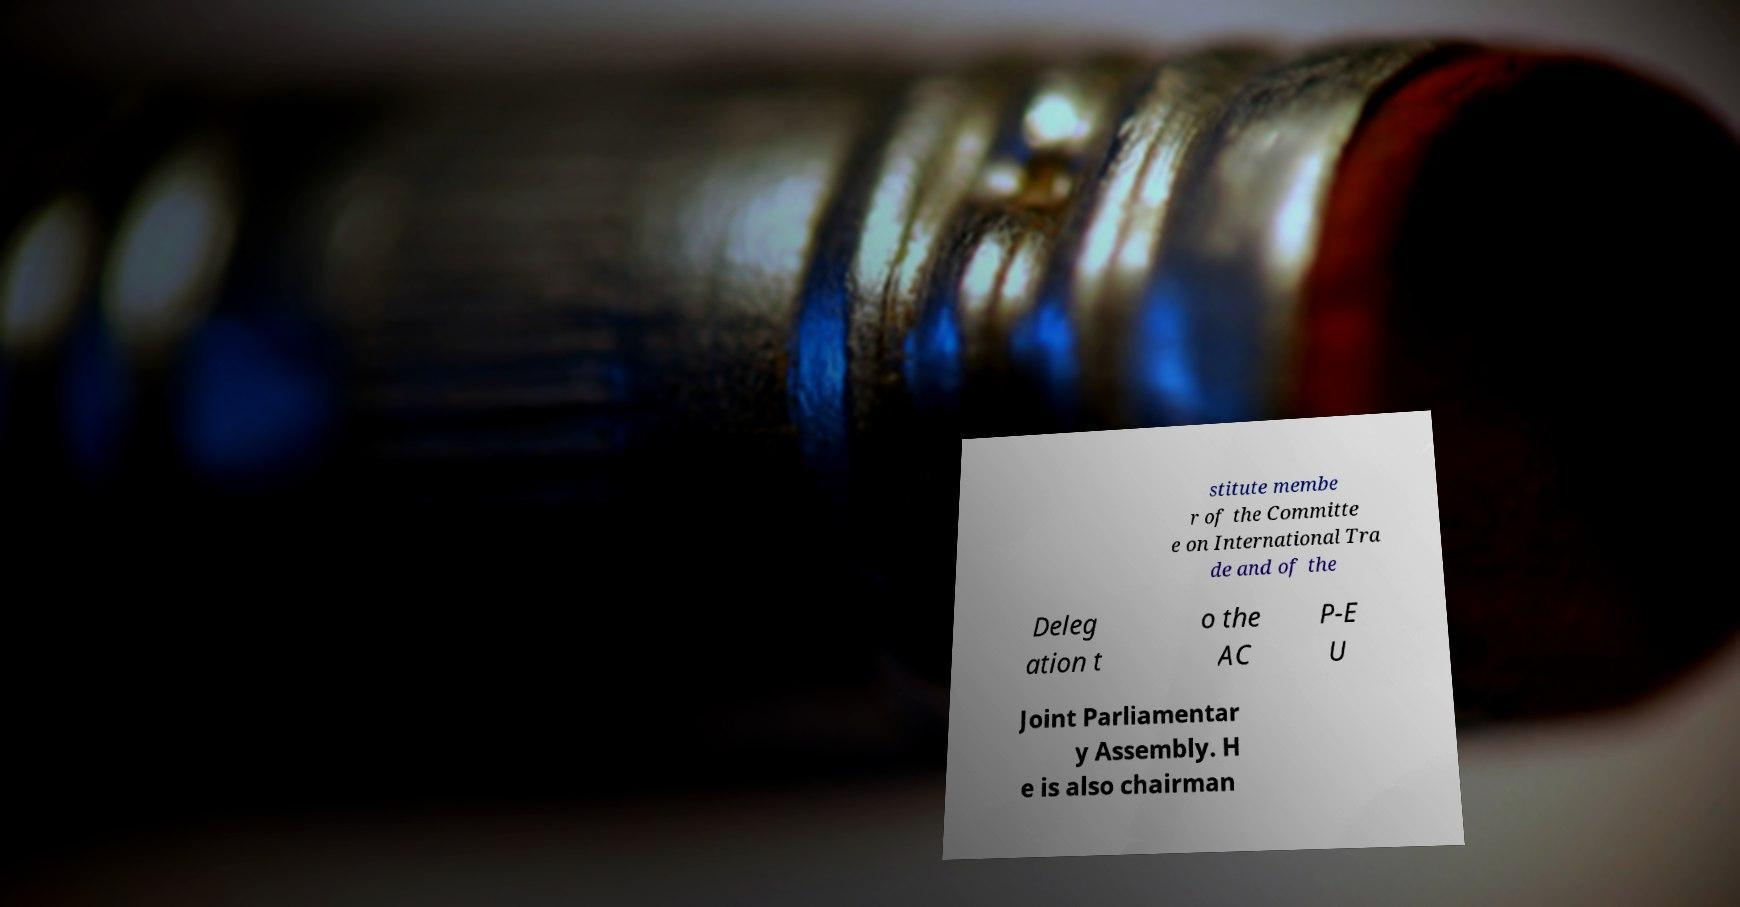What messages or text are displayed in this image? I need them in a readable, typed format. stitute membe r of the Committe e on International Tra de and of the Deleg ation t o the AC P-E U Joint Parliamentar y Assembly. H e is also chairman 